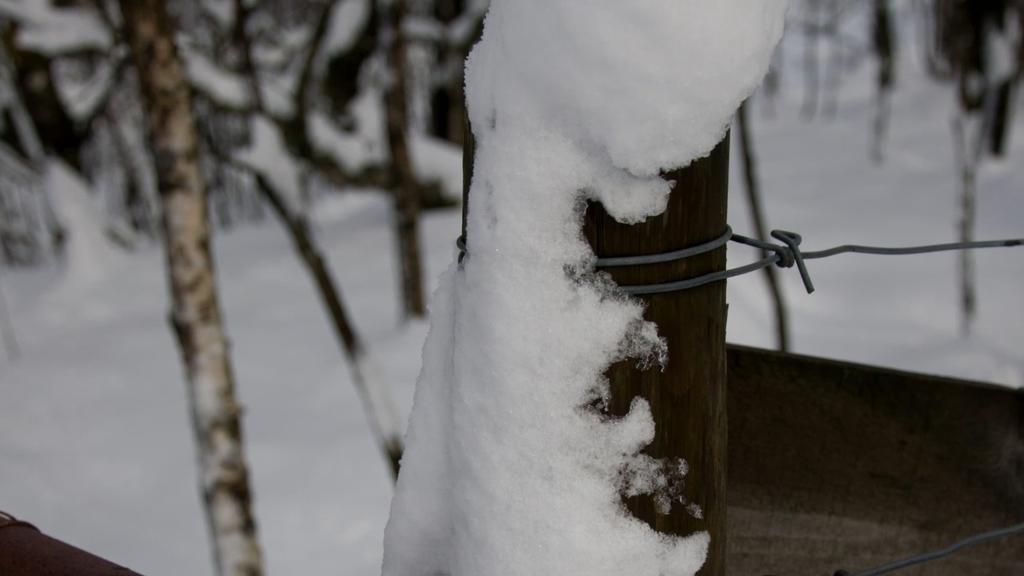In one or two sentences, can you explain what this image depicts? In this picture there is a bamboo in the center of the image, on which there is snow and there are trees in the background area of the image, there is snow around the area of the image. 